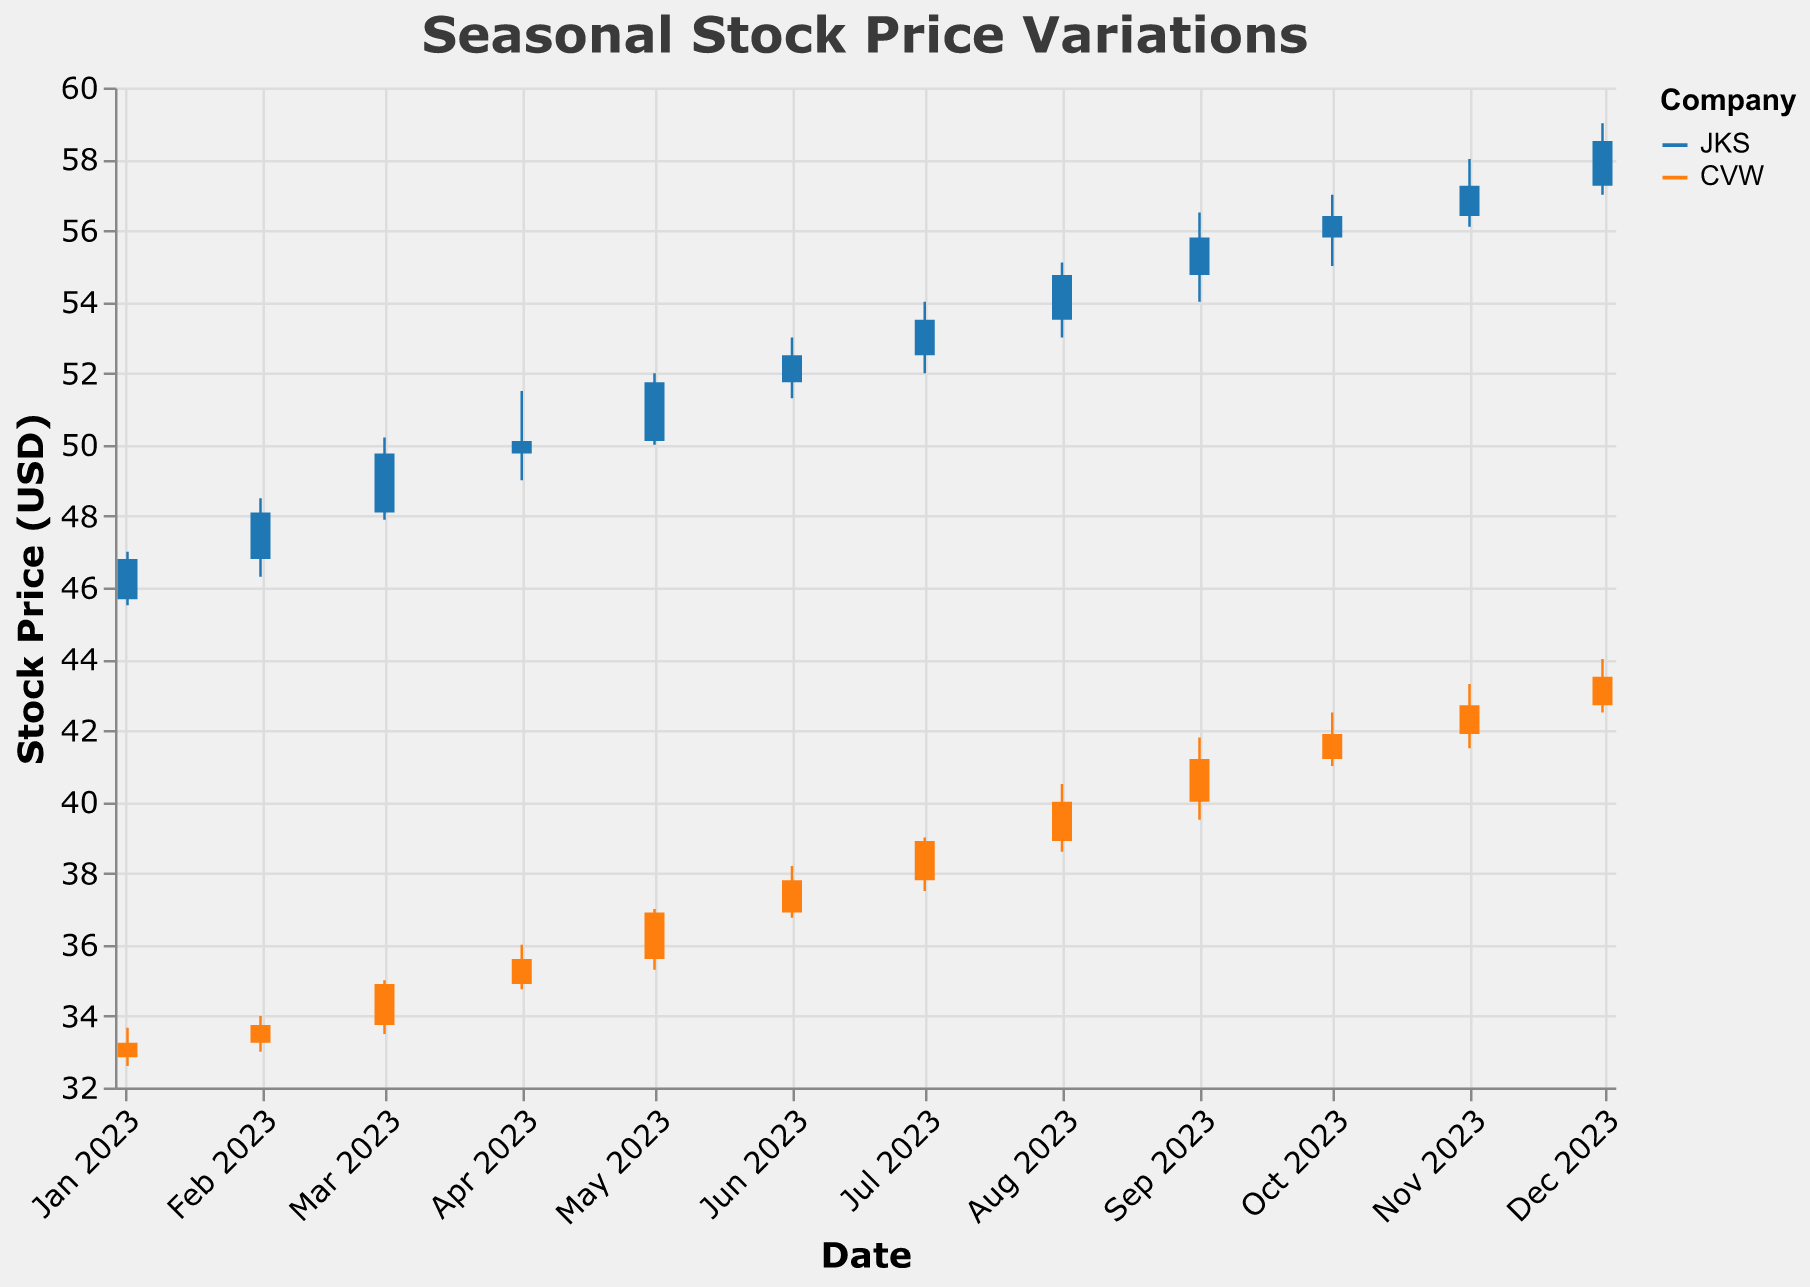What is the highest stock price for JKS in the dataset? To find the highest stock price for JKS, we need to look at the "High" values across all months for JKS. The highest value is 59.00 USD in December.
Answer: 59.00 USD Which company's stock price had a higher closing value in January 2023? Compare the "Close" values for JKS and CVW in January 2023. JKS has a closing value of 46.80 USD, and CVW has a closing value of 33.25 USD.
Answer: JKS By how much did the closing stock price of CVW increase from January 2023 to December 2023? Subtract the closing value in January (33.25 USD) from the closing value in December (43.50 USD). The increase is 43.50 - 33.25 = 10.25 USD.
Answer: 10.25 USD What month shows the highest trading volume for JKS? Check the "Volume" values for JKS across all months. The highest volume is 200,000 in December.
Answer: December How many months had an increasing trend in the closing prices for CVW from one month to the next? Compare the "Close" price of CVW for each consecutive month. Count the number of months where the closing price increased compared to the previous month. There are increases in February, March, April, May, June, July, August, September, October, November, and December.
Answer: 11 months Which company, JKS or CVW, had more volatility in stock prices in December 2023? Volatility can be approximated by looking at the difference between the "High" and "Low" prices. For JKS: 59.00 - 57.00 = 2.00 USD, for CVW: 44.00 - 42.50 = 1.50 USD. JKS shows more volatility.
Answer: JKS During which month did JKS and CVW both have their highest closing prices? Review the "Close" values and identify the months with the highest closing prices: JKS in December (58.50 USD) and CVW in December (43.50 USD).
Answer: December What is the average closing stock price for CVW across the entire year of 2023? Sum all the closing prices of CVW and divide by the number of months. (33.25 + 33.75 + 34.90 + 35.60 + 36.90 + 37.80 + 38.90 + 40.00 + 41.20 + 41.90 + 42.70 + 43.50) / 12 = 37.09 USD.
Answer: 37.09 USD In which month did JKS show the smallest range between its opening and closing prices? Calculate the difference between "Open" and "Close" prices for JKS in each month, then find the smallest difference. January: 46.80-45.67 = 1.13, February: 48.10-46.80 = 1.30, March: 49.75-48.10 = 1.65, April: 50.10-49.75 = 0.35, May: 51.75-50.10 = 1.65, June: 52.50-51.75 = 0.75, July: 53.50-52.50 = 1.00, August: 54.75-53.50 = 1.25, September: 55.80-54.75 = 1.05, October: 56.40-55.80 = 0.60, November: 57.25-56.40 = 0.85, December: 58.50-57.25 = 1.25. The smallest range is in April with 0.35 USD.
Answer: April 